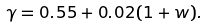<formula> <loc_0><loc_0><loc_500><loc_500>\gamma = 0 . 5 5 + 0 . 0 2 ( 1 + w ) .</formula> 